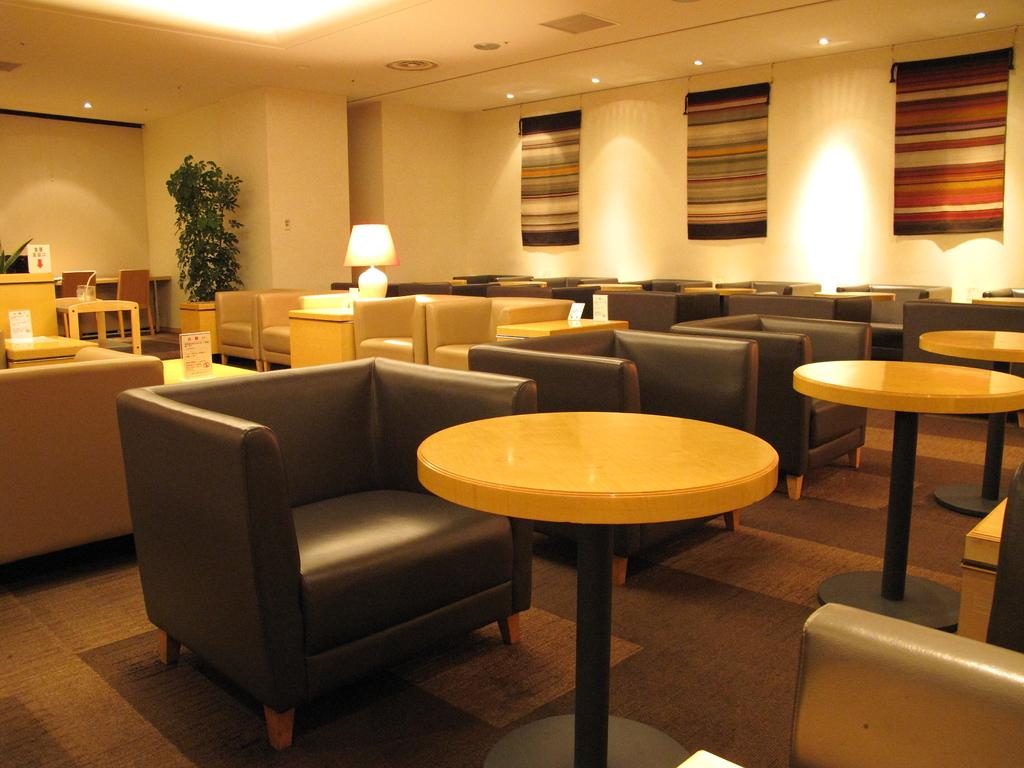What type of furniture is present in the image? There is a couch and a table in the image. What is located on the table in the image? There is a lamp on the table in the image. What can be seen in the background of the image? There is a wall in the background of the image. What is hanging on the wall in the image? There are curtains on the wall in the image. What is placed near the couch in the image? There is a flower pot in the image. How does the giraffe interact with the couch in the image? There is no giraffe present in the image; it only features a couch, a table, a lamp, a wall, curtains, and a flower pot. 